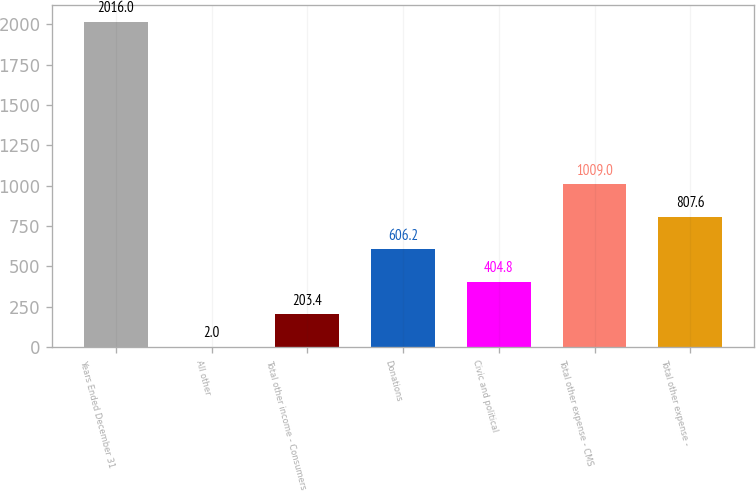Convert chart. <chart><loc_0><loc_0><loc_500><loc_500><bar_chart><fcel>Years Ended December 31<fcel>All other<fcel>Total other income - Consumers<fcel>Donations<fcel>Civic and political<fcel>Total other expense - CMS<fcel>Total other expense -<nl><fcel>2016<fcel>2<fcel>203.4<fcel>606.2<fcel>404.8<fcel>1009<fcel>807.6<nl></chart> 